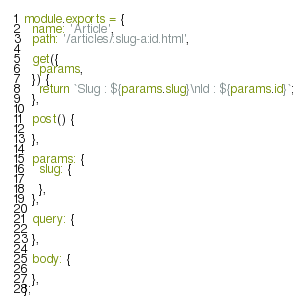Convert code to text. <code><loc_0><loc_0><loc_500><loc_500><_JavaScript_>module.exports = {
  name: 'Article',
  path: '/articles/:slug-a:id.html',

  get({
    params,
  }) {
    return `Slug : ${params.slug}\nId : ${params.id}`;
  },

  post() {

  },

  params: {
    slug: {

    },
  },

  query: {

  },

  body: {

  },
};
</code> 